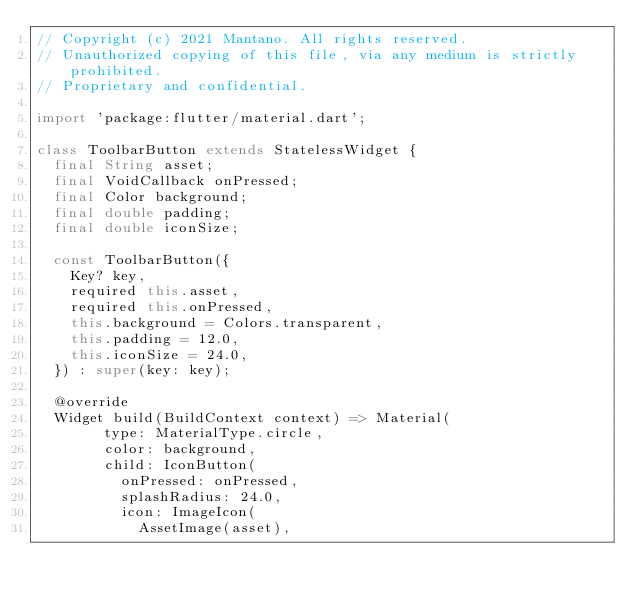Convert code to text. <code><loc_0><loc_0><loc_500><loc_500><_Dart_>// Copyright (c) 2021 Mantano. All rights reserved.
// Unauthorized copying of this file, via any medium is strictly prohibited.
// Proprietary and confidential.

import 'package:flutter/material.dart';

class ToolbarButton extends StatelessWidget {
  final String asset;
  final VoidCallback onPressed;
  final Color background;
  final double padding;
  final double iconSize;

  const ToolbarButton({
    Key? key,
    required this.asset,
    required this.onPressed,
    this.background = Colors.transparent,
    this.padding = 12.0,
    this.iconSize = 24.0,
  }) : super(key: key);

  @override
  Widget build(BuildContext context) => Material(
        type: MaterialType.circle,
        color: background,
        child: IconButton(
          onPressed: onPressed,
          splashRadius: 24.0,
          icon: ImageIcon(
            AssetImage(asset),</code> 